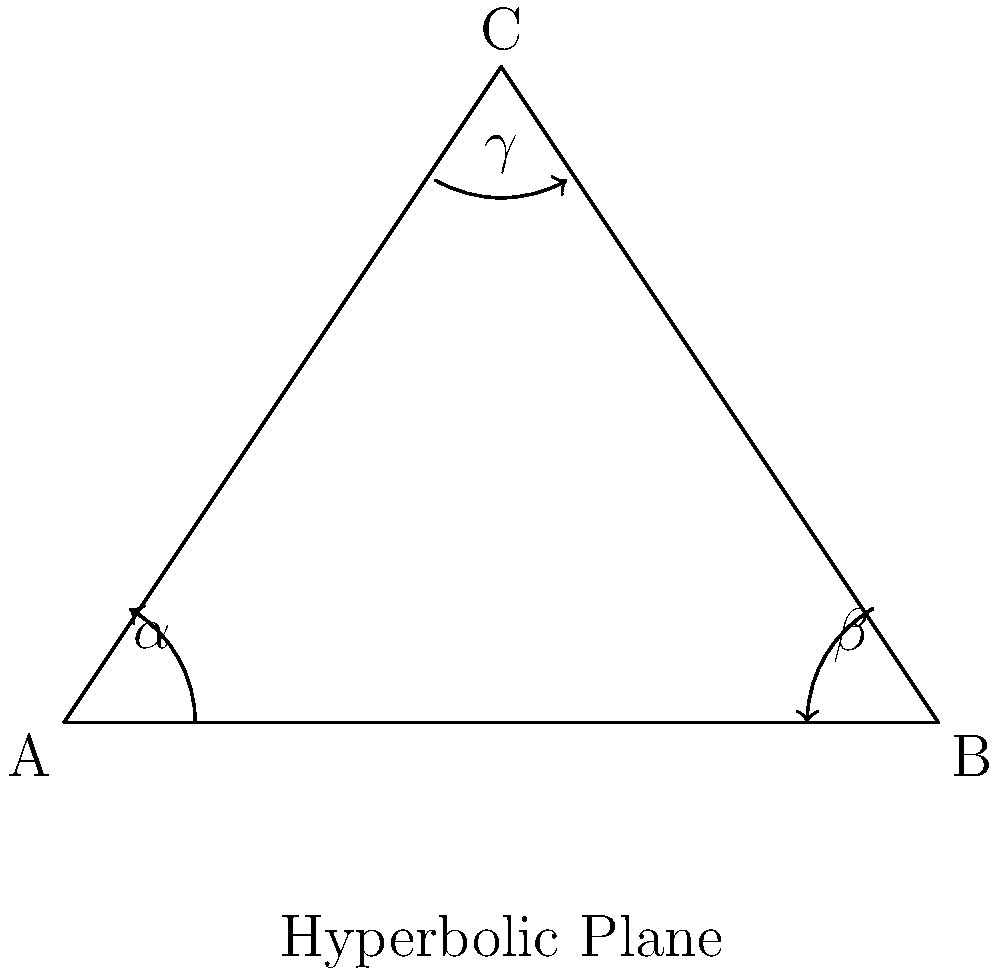In a hyperbolic plane, the sum of the angles in a triangle is always less than 180°. If the angles of a triangle on a hyperbolic plane are represented by $\alpha$, $\beta$, and $\gamma$, and the sum of these angles is 150°, what is the difference between this sum and the sum of angles in a Euclidean triangle? To solve this problem, let's follow these steps:

1. Recall that in Euclidean geometry, the sum of angles in a triangle is always 180°.

2. In the hyperbolic plane, we're given that the sum of angles is 150°:

   $$\alpha + \beta + \gamma = 150°$$

3. To find the difference, we need to subtract the hyperbolic sum from the Euclidean sum:

   $$\text{Difference} = \text{Euclidean sum} - \text{Hyperbolic sum}$$
   $$\text{Difference} = 180° - 150°$$
   $$\text{Difference} = 30°$$

This difference of 30° is often referred to as the "angle defect" in hyperbolic geometry. It represents how much the sum of angles in a hyperbolic triangle deviates from the Euclidean case.

Understanding this concept can help in grasping the fundamental differences between Euclidean and non-Euclidean geometries, which is crucial for advancing in more complex topics in mathematics and physics.
Answer: 30° 